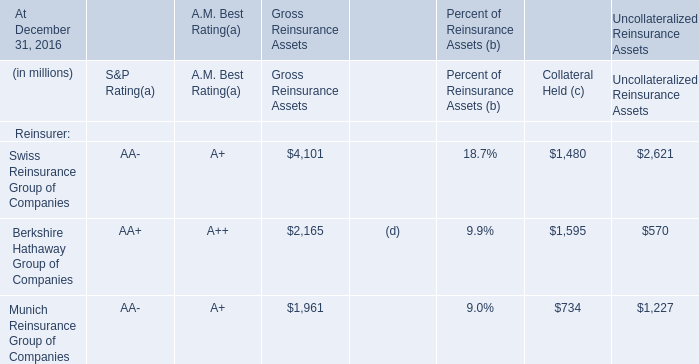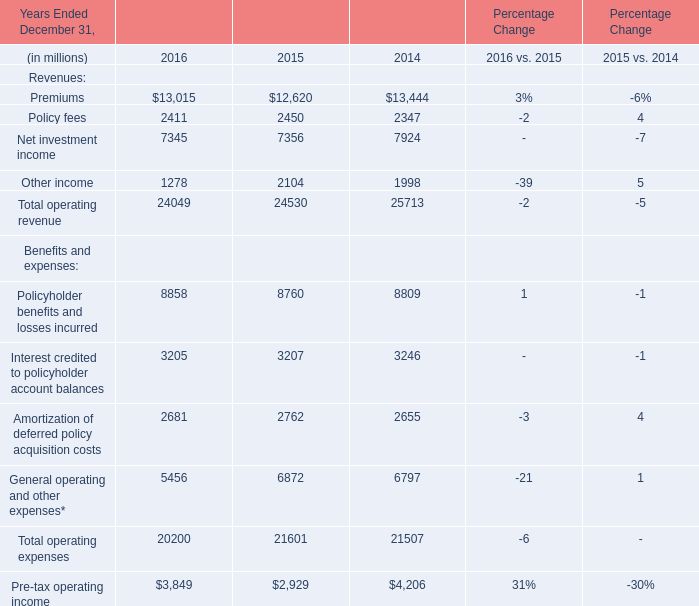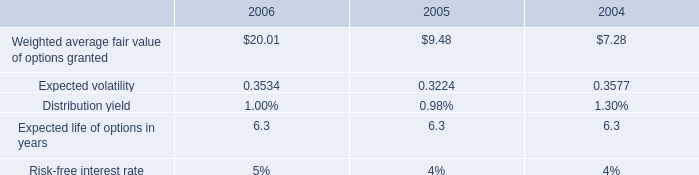What is the average amount of Other income of Percentage Change 2015, and Swiss Reinsurance Group of Companies of Gross Reinsurance Assets ? 
Computations: ((2104.0 + 4101.0) / 2)
Answer: 3102.5. 